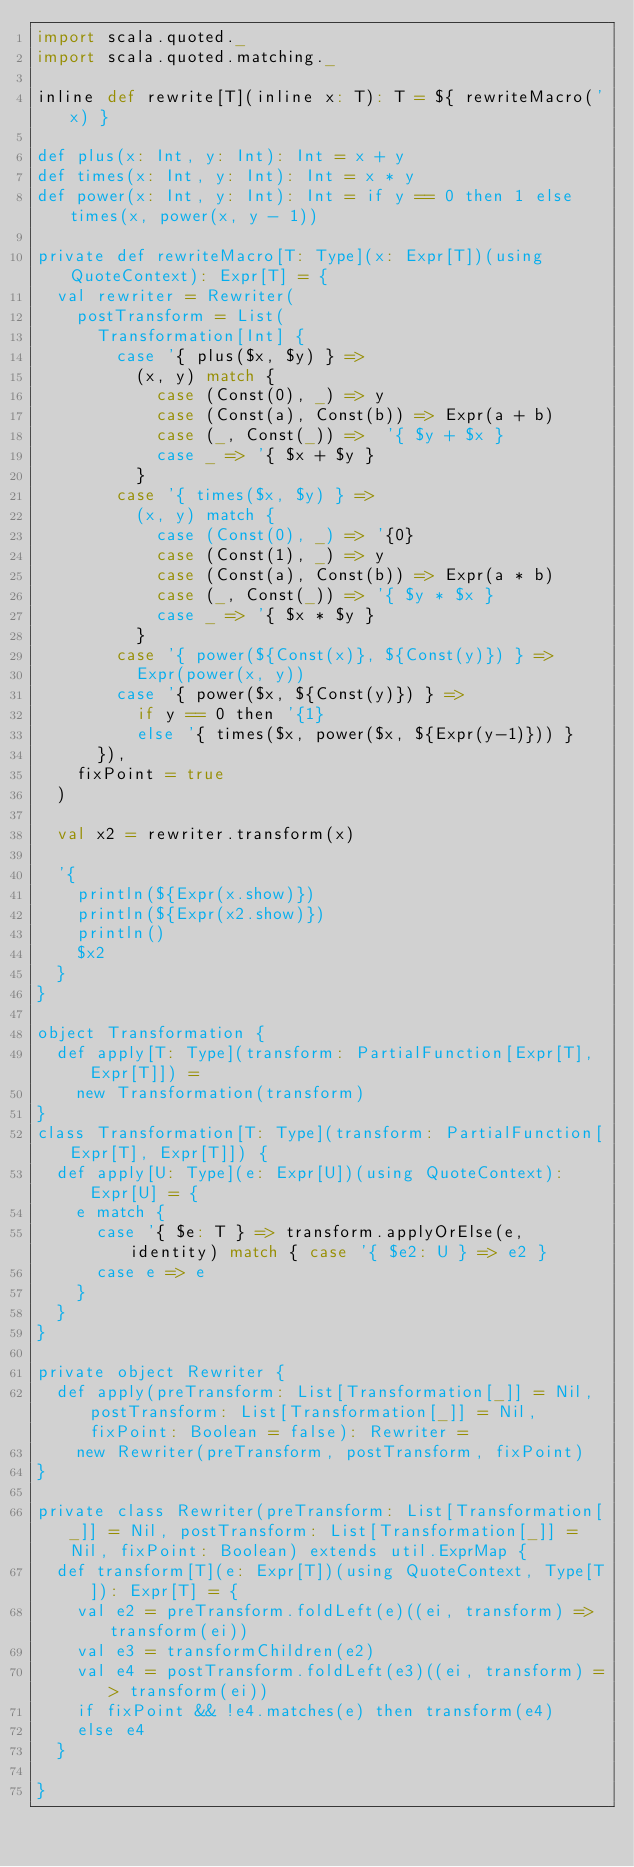<code> <loc_0><loc_0><loc_500><loc_500><_Scala_>import scala.quoted._
import scala.quoted.matching._

inline def rewrite[T](inline x: T): T = ${ rewriteMacro('x) }

def plus(x: Int, y: Int): Int = x + y
def times(x: Int, y: Int): Int = x * y
def power(x: Int, y: Int): Int = if y == 0 then 1 else times(x, power(x, y - 1))

private def rewriteMacro[T: Type](x: Expr[T])(using QuoteContext): Expr[T] = {
  val rewriter = Rewriter(
    postTransform = List(
      Transformation[Int] {
        case '{ plus($x, $y) } =>
          (x, y) match {
            case (Const(0), _) => y
            case (Const(a), Const(b)) => Expr(a + b)
            case (_, Const(_)) =>  '{ $y + $x }
            case _ => '{ $x + $y }
          }
        case '{ times($x, $y) } =>
          (x, y) match {
            case (Const(0), _) => '{0}
            case (Const(1), _) => y
            case (Const(a), Const(b)) => Expr(a * b)
            case (_, Const(_)) => '{ $y * $x }
            case _ => '{ $x * $y }
          }
        case '{ power(${Const(x)}, ${Const(y)}) } =>
          Expr(power(x, y))
        case '{ power($x, ${Const(y)}) } =>
          if y == 0 then '{1}
          else '{ times($x, power($x, ${Expr(y-1)})) }
      }),
    fixPoint = true
  )

  val x2 = rewriter.transform(x)

  '{
    println(${Expr(x.show)})
    println(${Expr(x2.show)})
    println()
    $x2
  }
}

object Transformation {
  def apply[T: Type](transform: PartialFunction[Expr[T], Expr[T]]) =
    new Transformation(transform)
}
class Transformation[T: Type](transform: PartialFunction[Expr[T], Expr[T]]) {
  def apply[U: Type](e: Expr[U])(using QuoteContext): Expr[U] = {
    e match {
      case '{ $e: T } => transform.applyOrElse(e, identity) match { case '{ $e2: U } => e2 }
      case e => e
    }
  }
}

private object Rewriter {
  def apply(preTransform: List[Transformation[_]] = Nil, postTransform: List[Transformation[_]] = Nil, fixPoint: Boolean = false): Rewriter =
    new Rewriter(preTransform, postTransform, fixPoint)
}

private class Rewriter(preTransform: List[Transformation[_]] = Nil, postTransform: List[Transformation[_]] = Nil, fixPoint: Boolean) extends util.ExprMap {
  def transform[T](e: Expr[T])(using QuoteContext, Type[T]): Expr[T] = {
    val e2 = preTransform.foldLeft(e)((ei, transform) => transform(ei))
    val e3 = transformChildren(e2)
    val e4 = postTransform.foldLeft(e3)((ei, transform) => transform(ei))
    if fixPoint && !e4.matches(e) then transform(e4)
    else e4
  }

}
</code> 